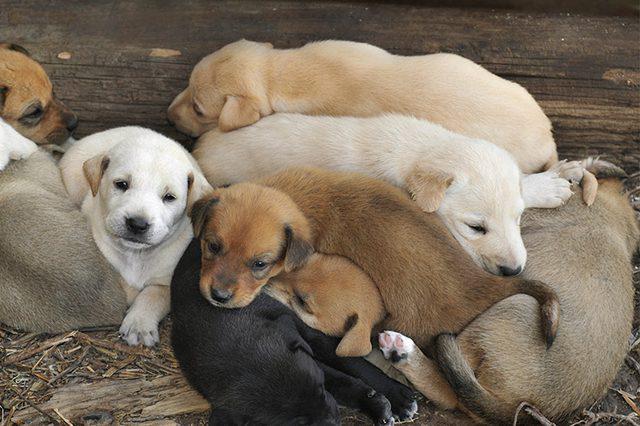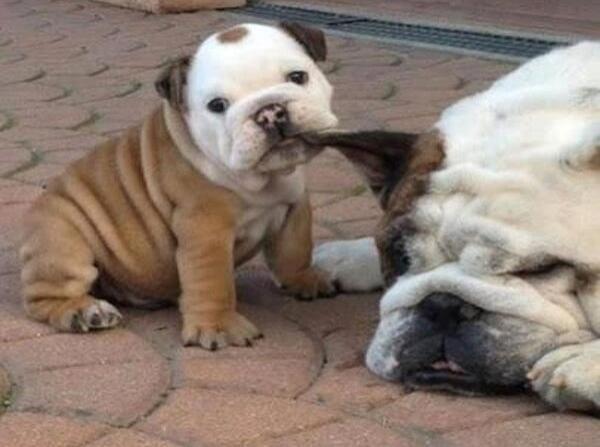The first image is the image on the left, the second image is the image on the right. For the images displayed, is the sentence "there are two puppies in the image pair" factually correct? Answer yes or no. No. The first image is the image on the left, the second image is the image on the right. Evaluate the accuracy of this statement regarding the images: "One dog has something around its neck.". Is it true? Answer yes or no. No. 